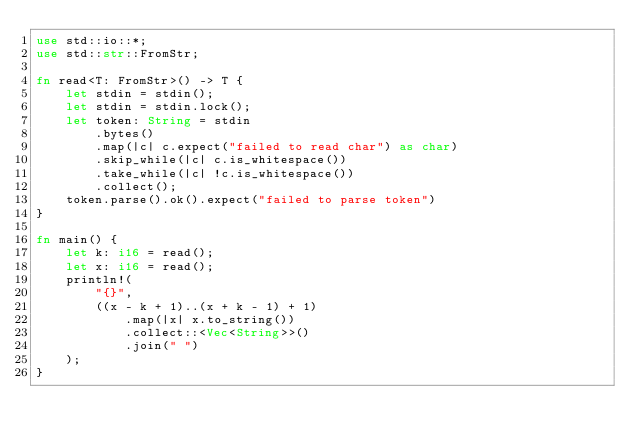Convert code to text. <code><loc_0><loc_0><loc_500><loc_500><_Rust_>use std::io::*;
use std::str::FromStr;

fn read<T: FromStr>() -> T {
    let stdin = stdin();
    let stdin = stdin.lock();
    let token: String = stdin
        .bytes()
        .map(|c| c.expect("failed to read char") as char)
        .skip_while(|c| c.is_whitespace())
        .take_while(|c| !c.is_whitespace())
        .collect();
    token.parse().ok().expect("failed to parse token")
}

fn main() {
    let k: i16 = read();
    let x: i16 = read();
    println!(
        "{}",
        ((x - k + 1)..(x + k - 1) + 1)
            .map(|x| x.to_string())
            .collect::<Vec<String>>()
            .join(" ")
    );
}
</code> 